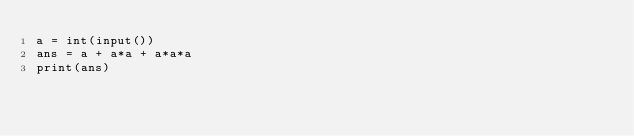<code> <loc_0><loc_0><loc_500><loc_500><_Python_>a = int(input())
ans = a + a*a + a*a*a
print(ans)</code> 